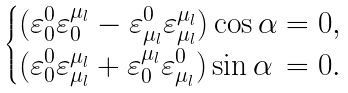<formula> <loc_0><loc_0><loc_500><loc_500>\begin{cases} ( { \varepsilon } ^ { 0 } _ { 0 } { \varepsilon } ^ { { \mu } _ { l } } _ { 0 } - { \varepsilon } ^ { 0 } _ { { \mu } _ { l } } { \varepsilon } _ { { \mu } _ { l } } ^ { { \mu } _ { l } } ) \cos \alpha = 0 , \\ ( { \varepsilon } ^ { 0 } _ { 0 } { \varepsilon } _ { { \mu } _ { l } } ^ { { \mu } _ { l } } + { \varepsilon } ^ { { \mu } _ { l } } _ { 0 } { \varepsilon } ^ { 0 } _ { { \mu } _ { l } } ) \sin \alpha \, = 0 . \end{cases}</formula> 